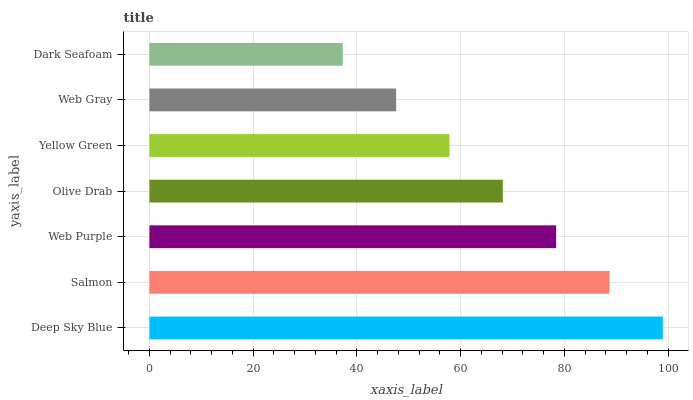Is Dark Seafoam the minimum?
Answer yes or no. Yes. Is Deep Sky Blue the maximum?
Answer yes or no. Yes. Is Salmon the minimum?
Answer yes or no. No. Is Salmon the maximum?
Answer yes or no. No. Is Deep Sky Blue greater than Salmon?
Answer yes or no. Yes. Is Salmon less than Deep Sky Blue?
Answer yes or no. Yes. Is Salmon greater than Deep Sky Blue?
Answer yes or no. No. Is Deep Sky Blue less than Salmon?
Answer yes or no. No. Is Olive Drab the high median?
Answer yes or no. Yes. Is Olive Drab the low median?
Answer yes or no. Yes. Is Web Purple the high median?
Answer yes or no. No. Is Web Gray the low median?
Answer yes or no. No. 